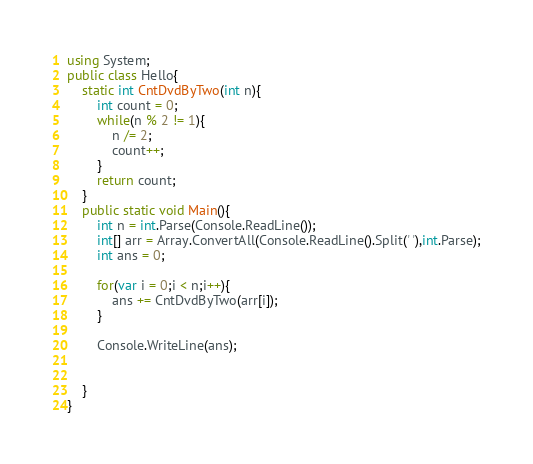Convert code to text. <code><loc_0><loc_0><loc_500><loc_500><_C#_>using System;
public class Hello{
    static int CntDvdByTwo(int n){
        int count = 0;
        while(n % 2 != 1){
            n /= 2;
            count++;
        }
        return count;
    }
    public static void Main(){
        int n = int.Parse(Console.ReadLine());
        int[] arr = Array.ConvertAll(Console.ReadLine().Split(' '),int.Parse);
        int ans = 0;
        
        for(var i = 0;i < n;i++){
            ans += CntDvdByTwo(arr[i]);
        }
        
        Console.WriteLine(ans);
            
        
    }
}
</code> 